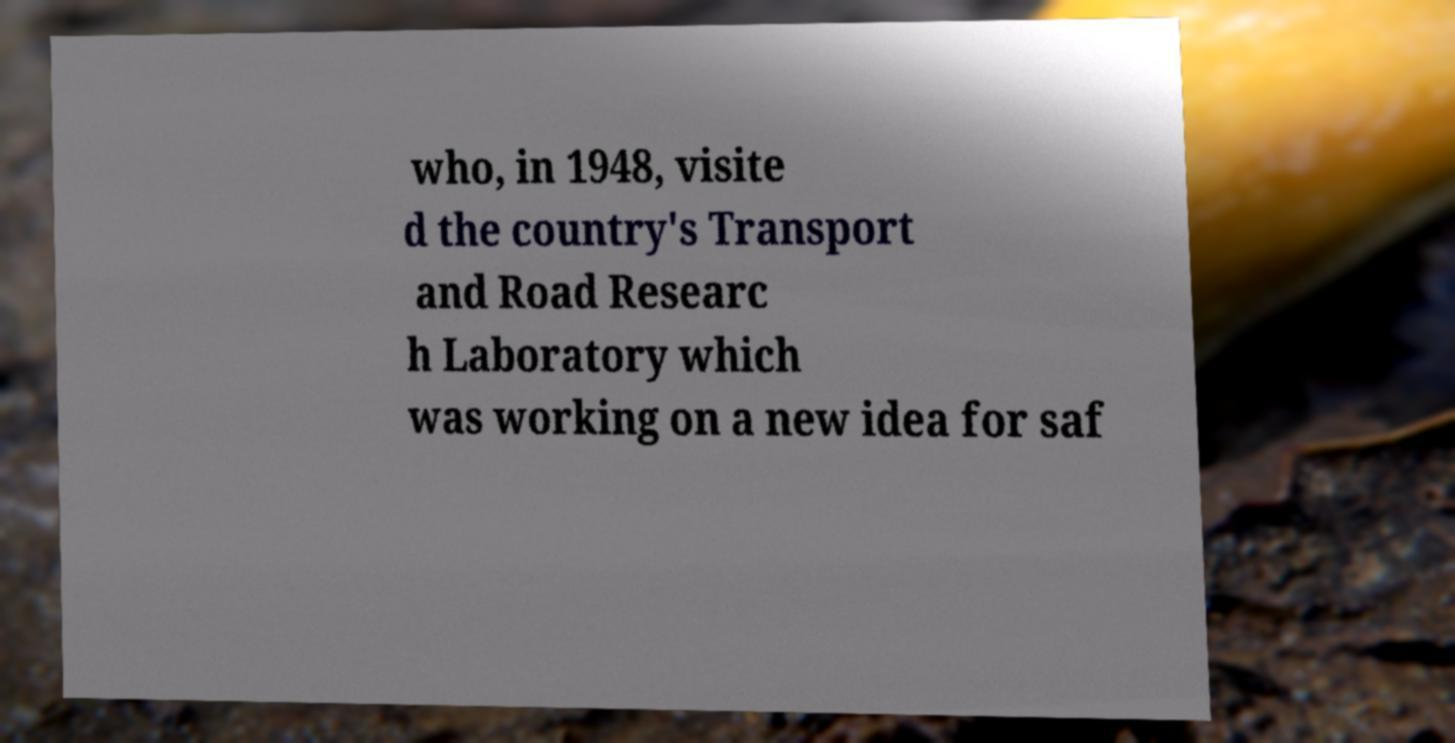Can you accurately transcribe the text from the provided image for me? who, in 1948, visite d the country's Transport and Road Researc h Laboratory which was working on a new idea for saf 